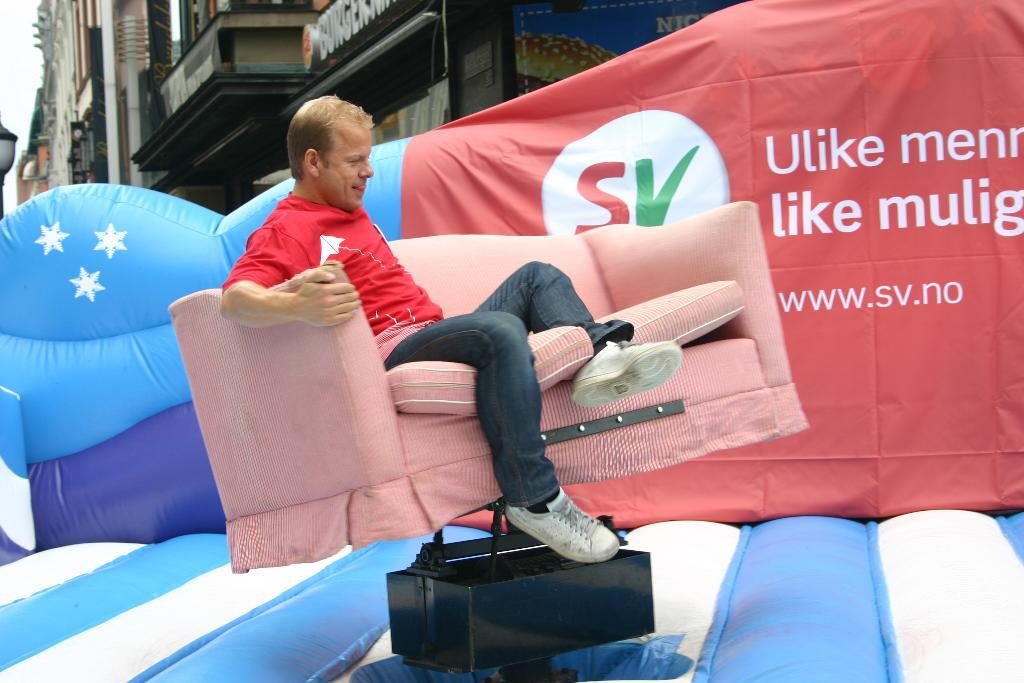What is the person in the image doing? The person is sitting on a sofa. What is the person's facial expression? The person is smiling. What can be seen in the background of the image? There are buildings visible in the background. What type of collar is the person wearing in the image? There is no collar visible in the image, as the person is not wearing any clothing that would have a collar. 